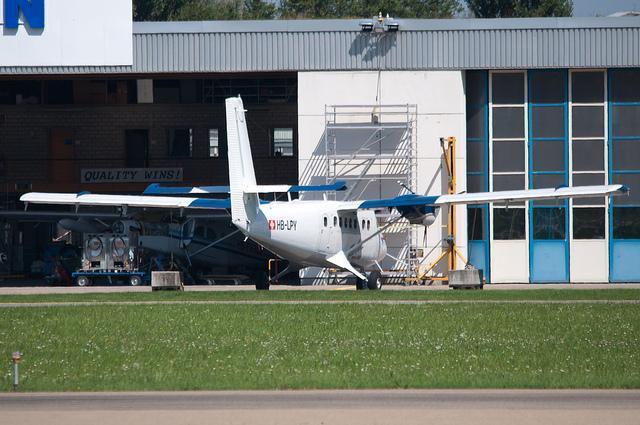How many airplanes are there?
Give a very brief answer. 2. 